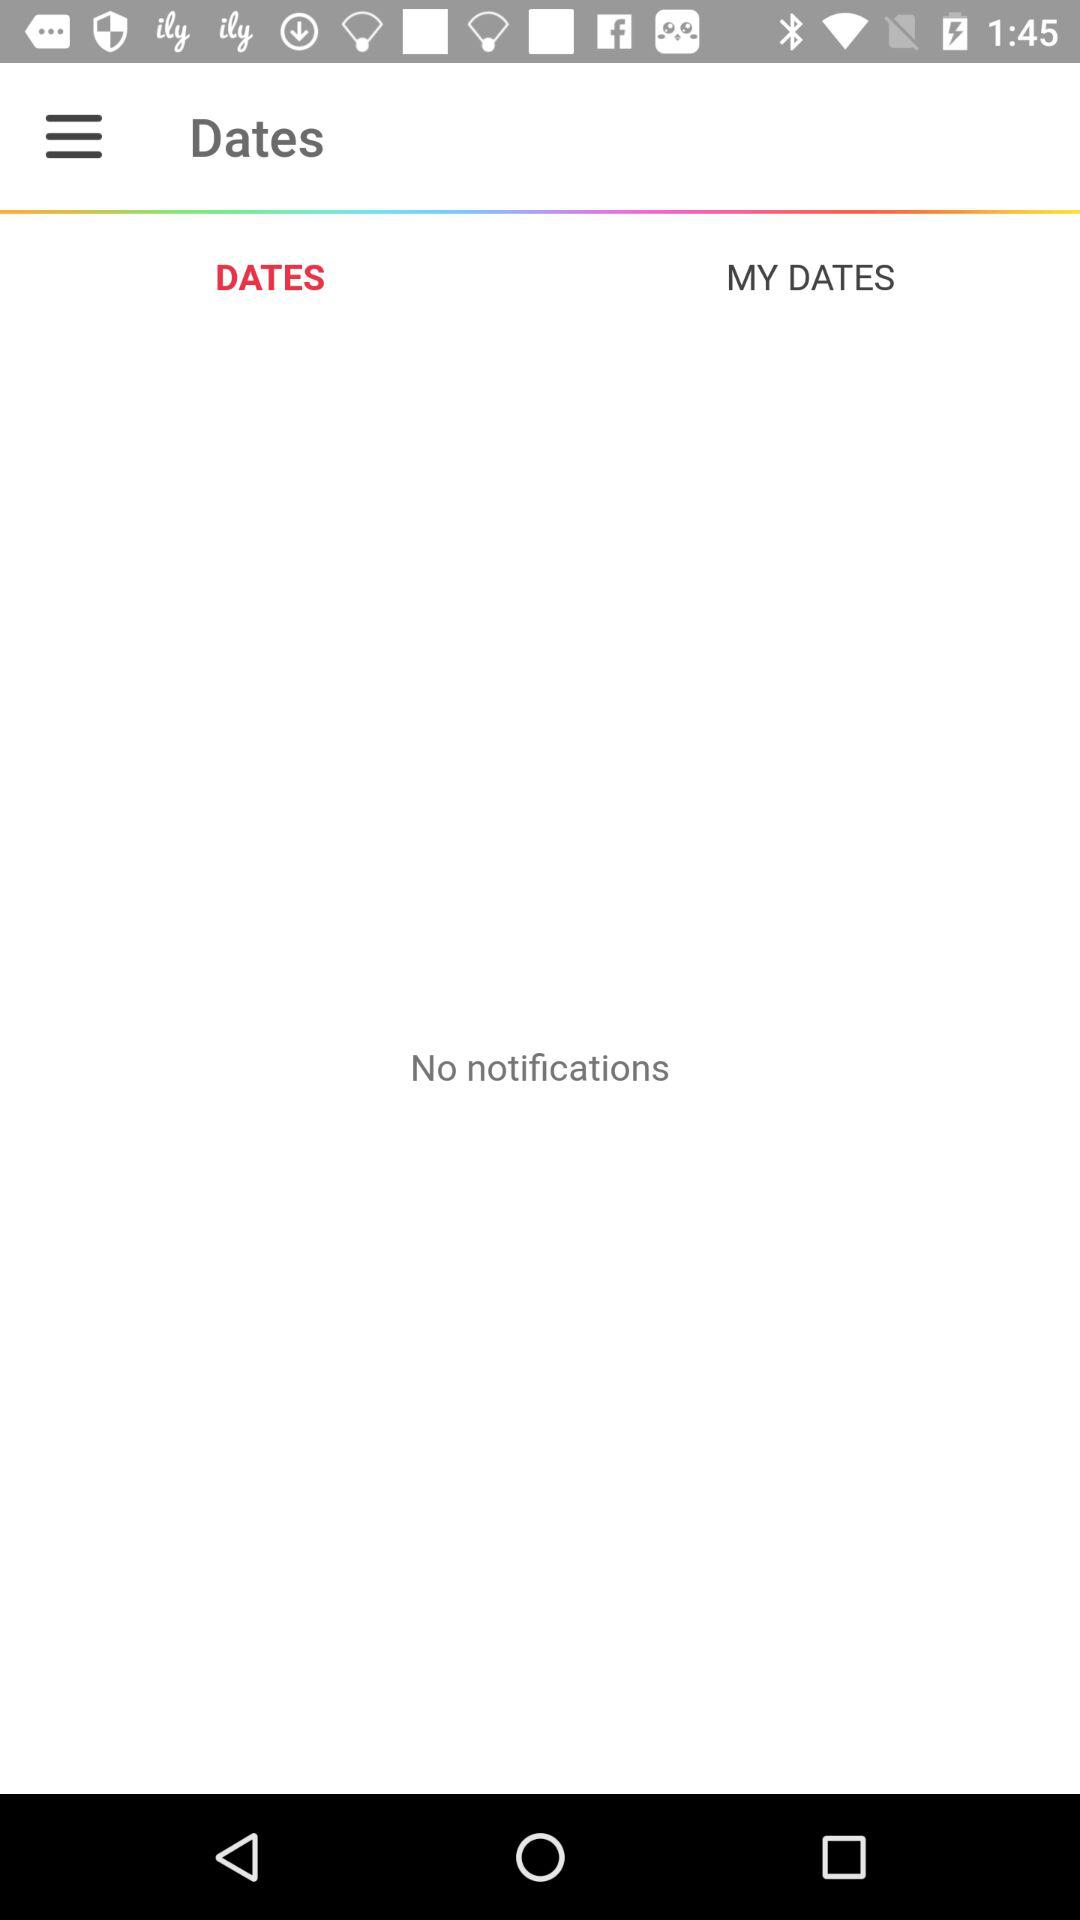Which tab is selected? The selected tab is "DATES". 